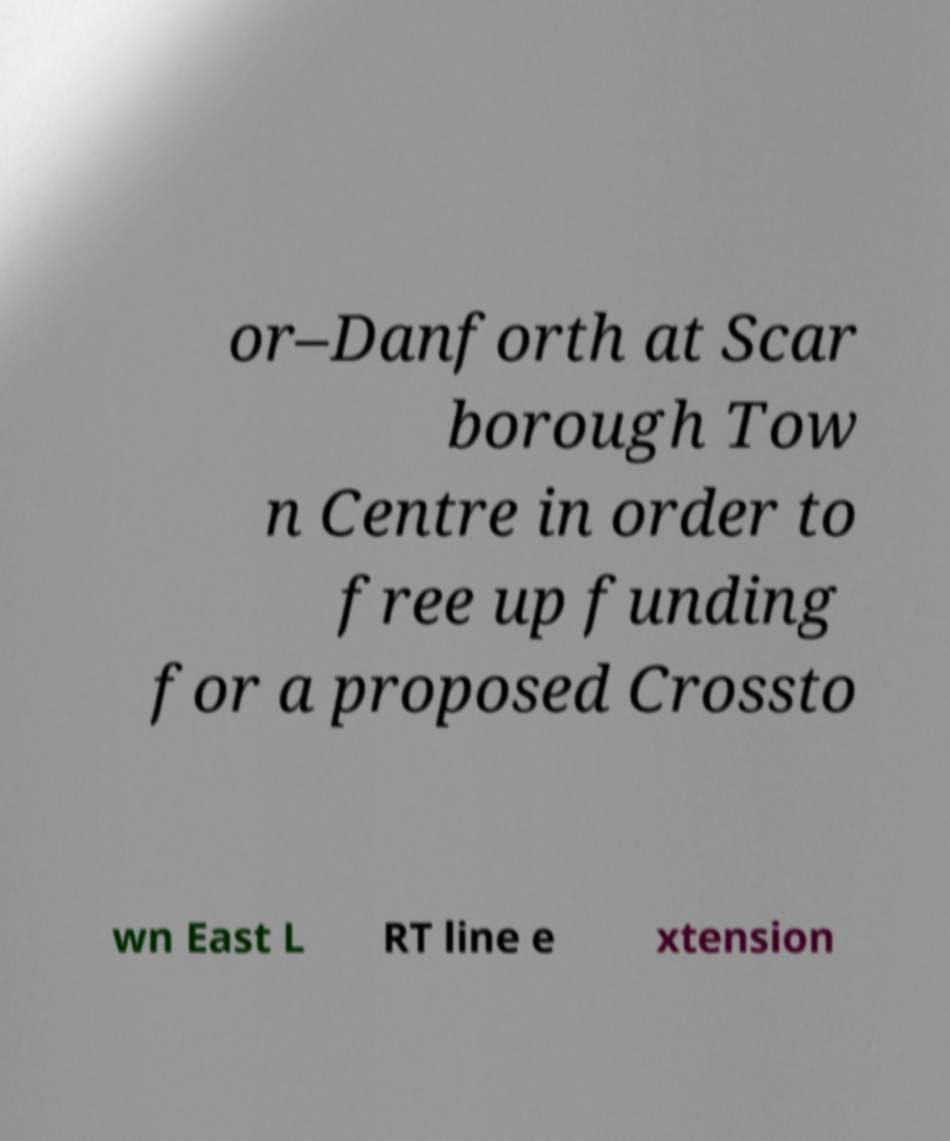I need the written content from this picture converted into text. Can you do that? or–Danforth at Scar borough Tow n Centre in order to free up funding for a proposed Crossto wn East L RT line e xtension 